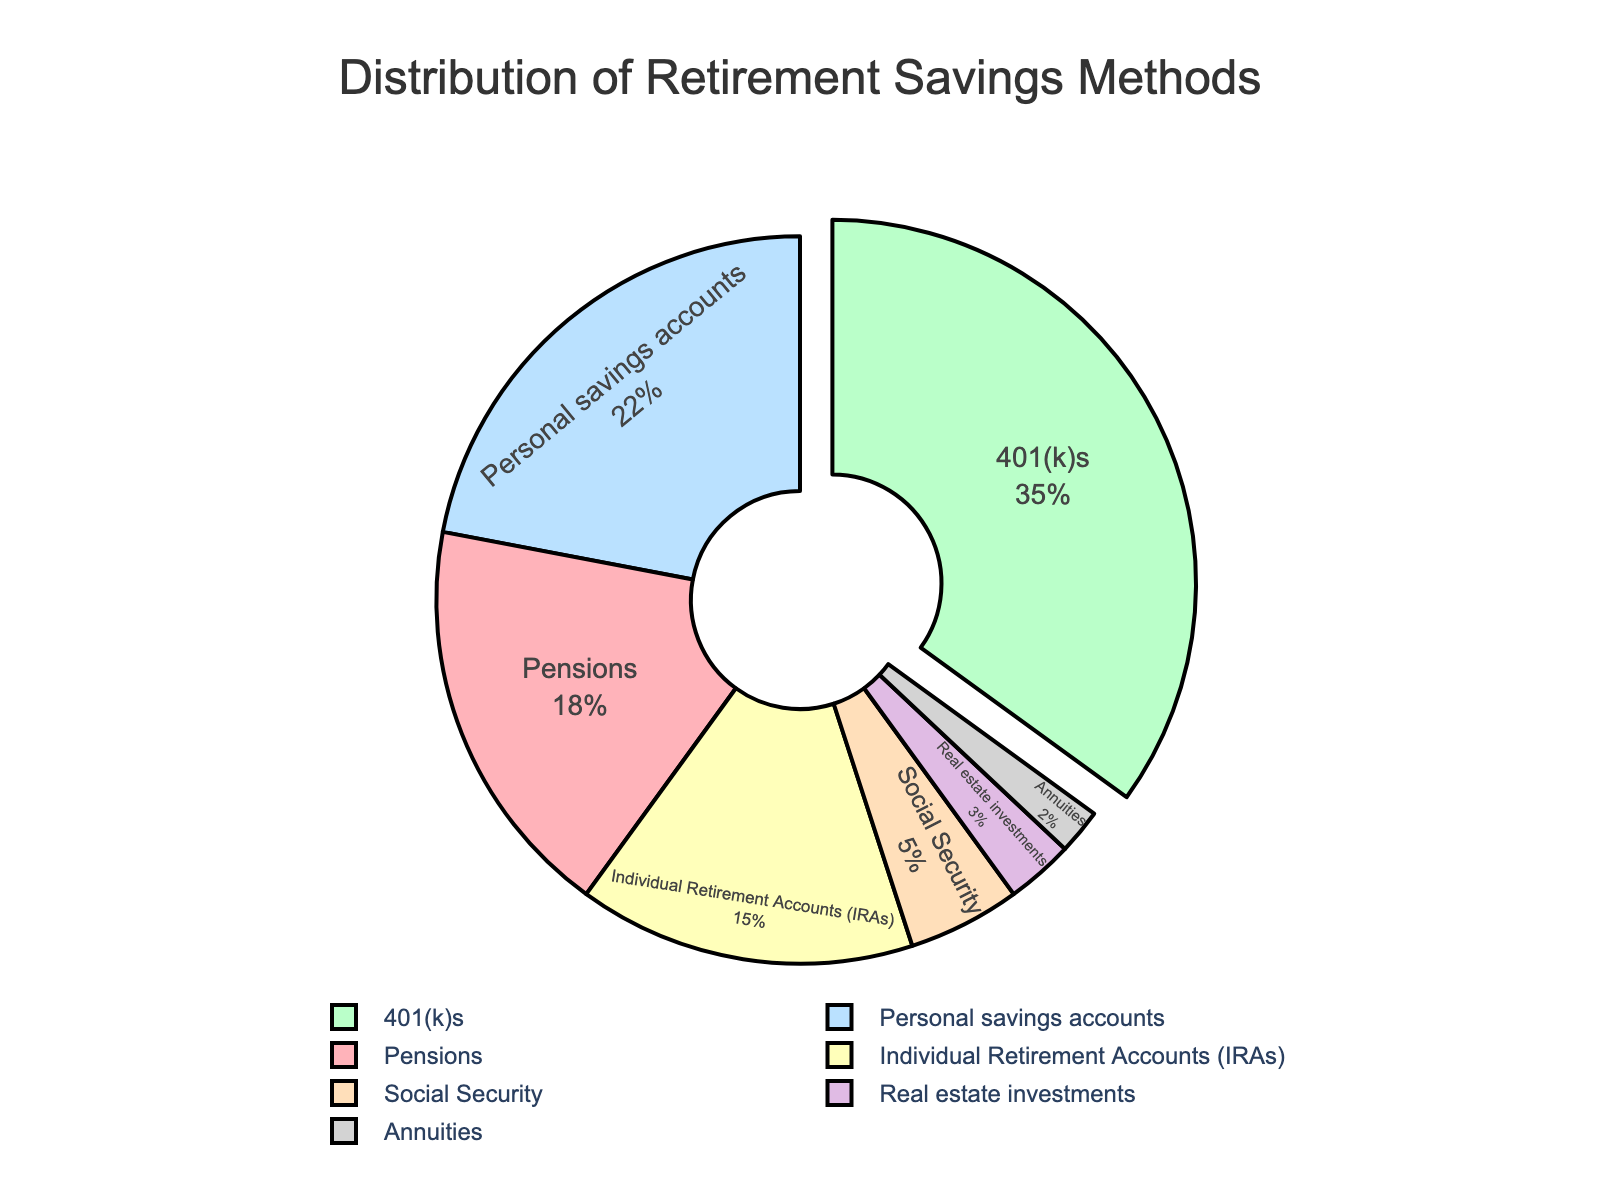Which retirement savings method has the highest percentage? The pie chart pulls the section with the highest percentage slightly outwards for emphasis. The label "35%" next to 401(k)s indicates it has the highest percentage among all the listed methods.
Answer: 401(k)s How much higher is the percentage of 401(k)s compared to pensions? The percentage for 401(k)s is 35%, and for pensions, it is 18%. The difference is calculated as 35% - 18%.
Answer: 17% What is the combined percentage of pensions and personal savings accounts? The percentage for pensions is 18%, and for personal savings accounts, it is 22%. Adding these together, 18% + 22%, gives the total.
Answer: 40% What is the least common retirement savings method and its percentage? The section with the smallest size on the pie chart represents annuities, which is labeled with 2%.
Answer: Annuities, 2% How does the percentage of IRAs compare to real estate investments? The percentage for IRAs is 15%, and for real estate investments, it is 3%. IRAs have a greater percentage.
Answer: IRAs > Real estate investments What percentage does Medicare represent on the chart? The figure does not include Medicare among the retirement savings methods listed.
Answer: Not represented What is the total percentage represented by all retirement savings methods shown in the pie chart? Summing the percentages of all methods listed: 18% (pensions) + 35% (401(k)s) + 22% (personal savings) + 15% (IRAs) + 5% (Social Security) + 3% (real estate investments) + 2% (annuities) results in 100%.
Answer: 100% What color represents Social Security on the pie chart? The visual attributes indicate Social Security is represented with a unique color in the pie chart. The section labeled 5% is yellow.
Answer: Yellow Which retirement savings methods have a percentage less than 10%? The sections labeled less than 10% are Social Security (5%), real estate investments (3%), and annuities (2%).
Answer: Social Security, Real estate investments, Annuities How many retirement savings methods have a percentage greater than or equal to 15%? Methods with percentages greater than or equal to 15% are pensions (18%), 401(k)s (35%), personal savings accounts (22%), and IRAs (15%). There are four such methods.
Answer: 4 